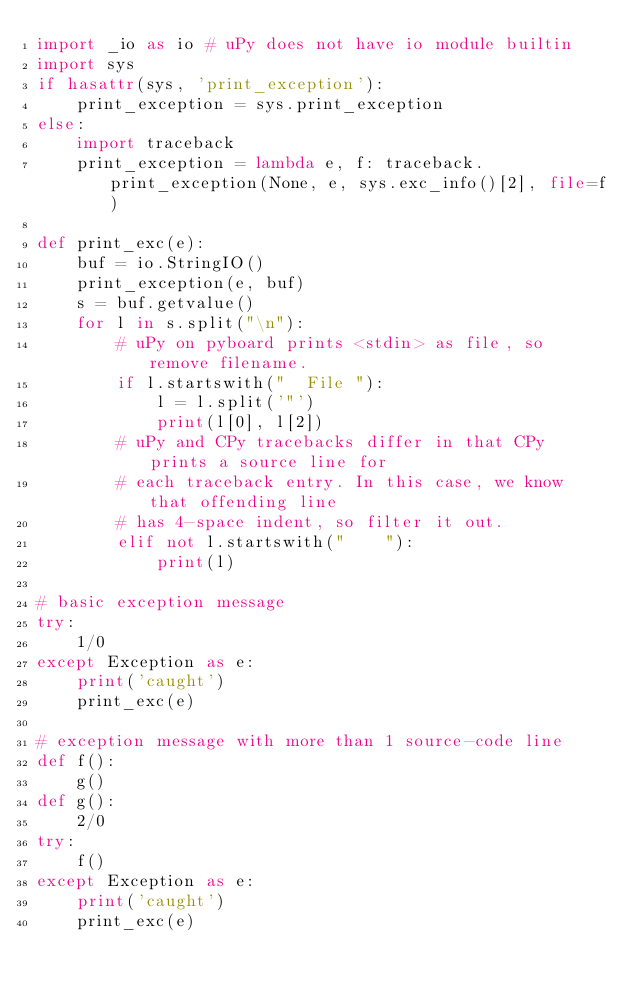<code> <loc_0><loc_0><loc_500><loc_500><_Python_>import _io as io # uPy does not have io module builtin
import sys
if hasattr(sys, 'print_exception'):
    print_exception = sys.print_exception
else:
    import traceback
    print_exception = lambda e, f: traceback.print_exception(None, e, sys.exc_info()[2], file=f)

def print_exc(e):
    buf = io.StringIO()
    print_exception(e, buf)
    s = buf.getvalue()
    for l in s.split("\n"):
        # uPy on pyboard prints <stdin> as file, so remove filename.
        if l.startswith("  File "):
            l = l.split('"')
            print(l[0], l[2])
        # uPy and CPy tracebacks differ in that CPy prints a source line for
        # each traceback entry. In this case, we know that offending line
        # has 4-space indent, so filter it out.
        elif not l.startswith("    "):
            print(l)

# basic exception message
try:
    1/0
except Exception as e:
    print('caught')
    print_exc(e)

# exception message with more than 1 source-code line
def f():
    g()
def g():
    2/0
try:
    f()
except Exception as e:
    print('caught')
    print_exc(e)
</code> 